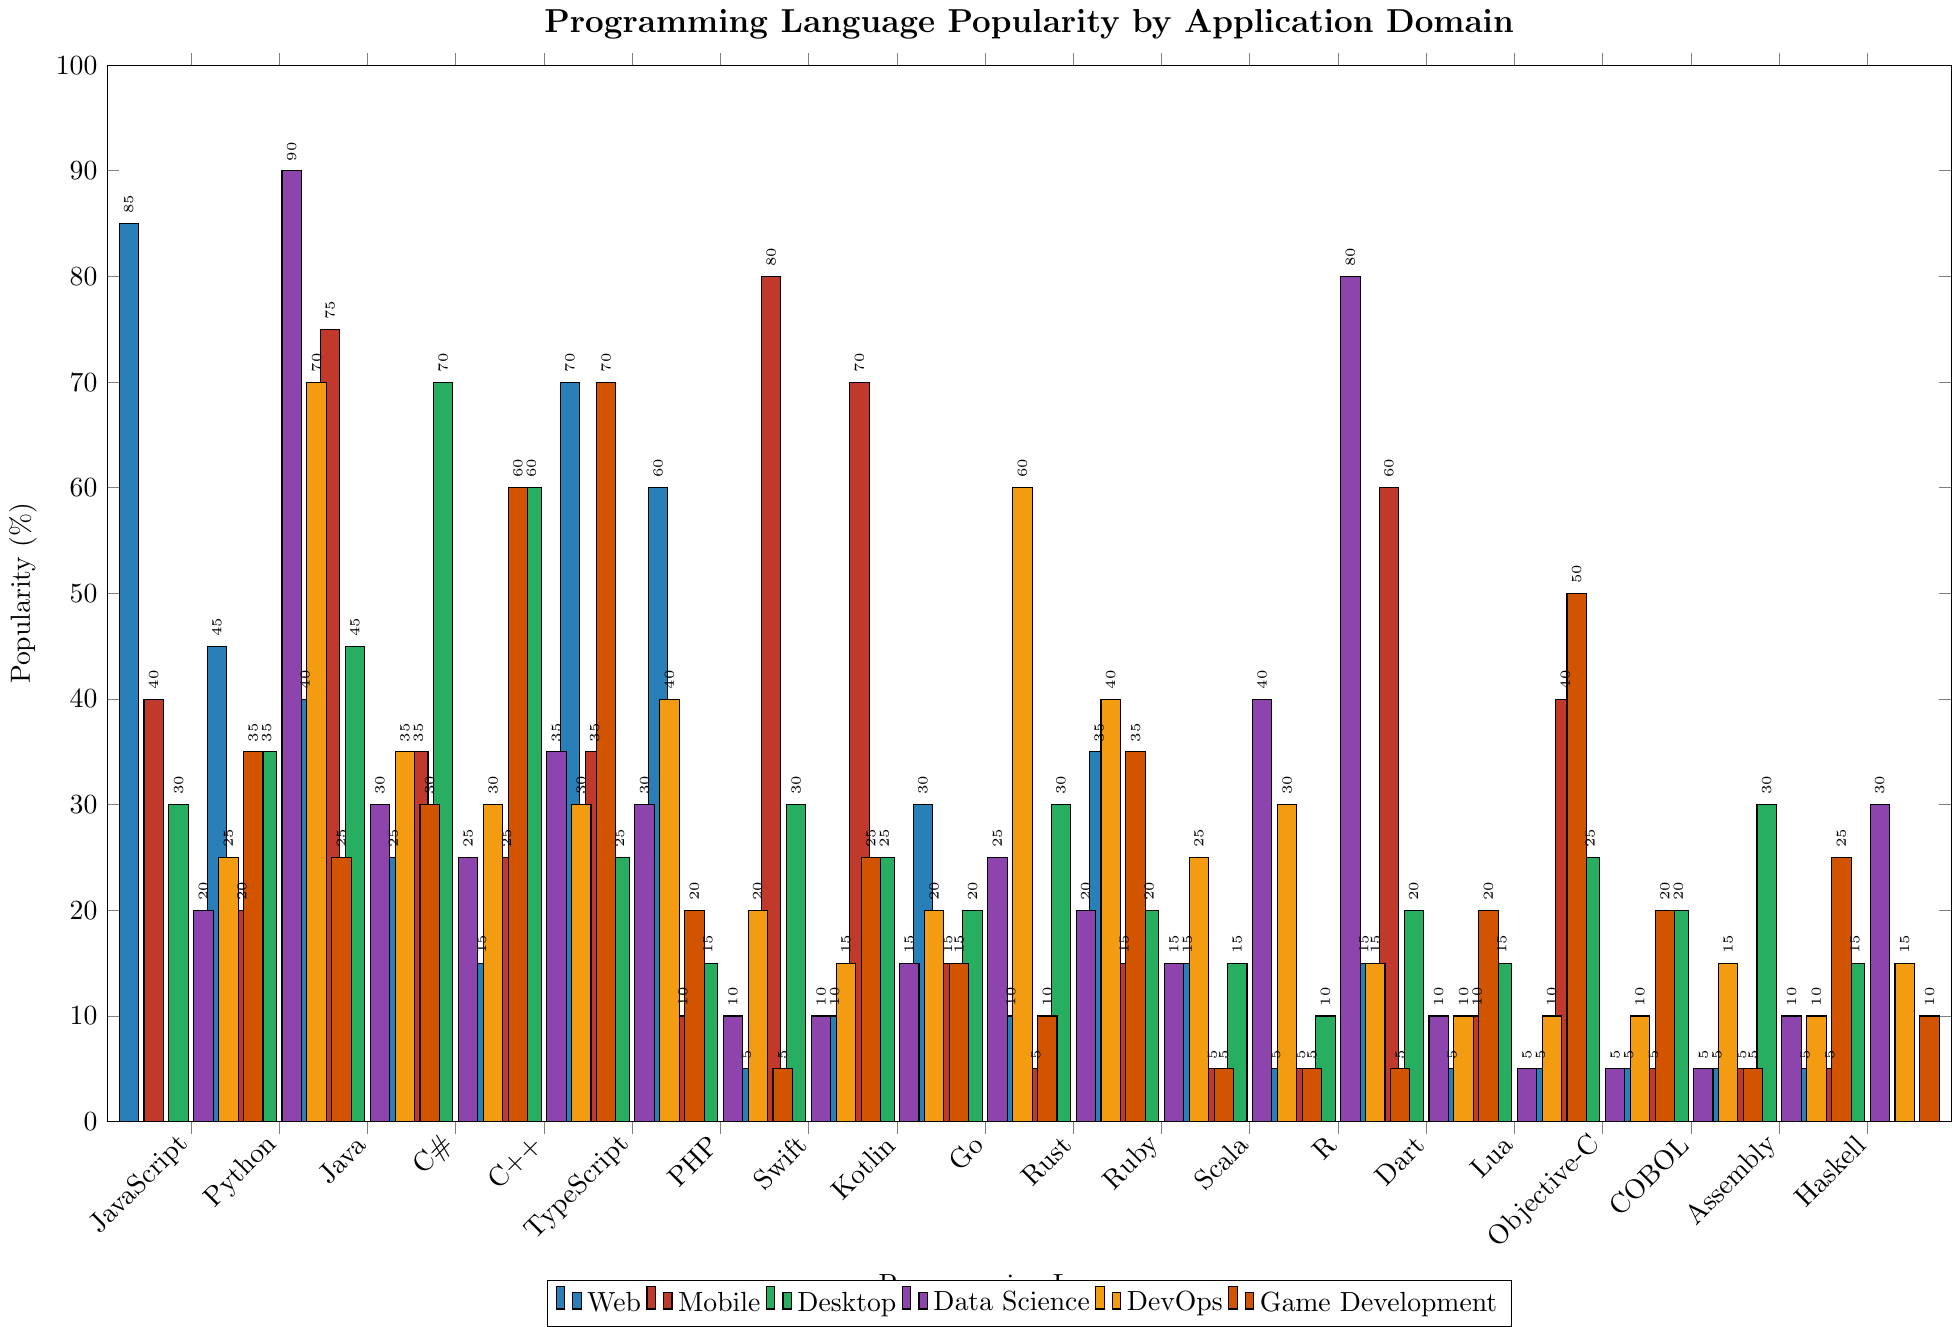What is the most popular language for mobile development? Identify the highest bar for the mobile development category, which is the red bar that corresponds to Swift.
Answer: Swift Which language is more popular for data science: Python or R? Compare the heights of the purple bars for Python and R. Python has a higher bar at 90% compared to R's height of 80%.
Answer: Python What is the least popular language for game development? Find the shortest orange bar in the game development category. PHP has the shortest bar at 5%.
Answer: PHP How does the popularity of JavaScript in web development compare to its popularity in game development? Compare the heights of the blue bar for JavaScript (web) and the orange bar for JavaScript (game development). JavaScript is more popular in web development (85%) than in game development (35%).
Answer: More popular in web development What is the total popularity percentage of Python across all application domains? Add the percentages of Python in each category: 45 (web) + 20 (mobile) + 35 (desktop) + 90 (data science) + 70 (DevOps) + 25 (game development) = 285%.
Answer: 285% For which domains is C++ more popular than JavaScript? Compare the bars of C++ and JavaScript across all domains. C++ is more popular in desktop (60% vs. 30%) and game development (70% vs. 35%).
Answer: Desktop, Game Development Is Kotlin more popular for mobile or data science applications? Compare the red bar (mobile) and the purple bar (data science) for Kotlin. Kotlin is more popular in mobile development (70%) than in data science (15%).
Answer: Mobile How many languages have web popularity above 50%? Identify the languages with blue bars above the 50% mark: JavaScript (85%), TypeScript (70%), and PHP (60%). There are 3 languages in total.
Answer: 3 Compare the popularity of Assembly and COBOL in desktop and data science applications. For desktop: Assembly (30%) vs. COBOL (20%). For data science: Assembly (10%) vs. COBOL (5%). Assembly is more popular in both desktop and data science.
Answer: Assembly more popular in both What is the average popularity of Go across all domains? Calculate the average by summing up Go's percentages in all categories and dividing by the number of domains: (30 + 15 + 20 + 25 + 60 + 10) / 6 = 160 / 6 ≈ 26.67%.
Answer: 26.67% 